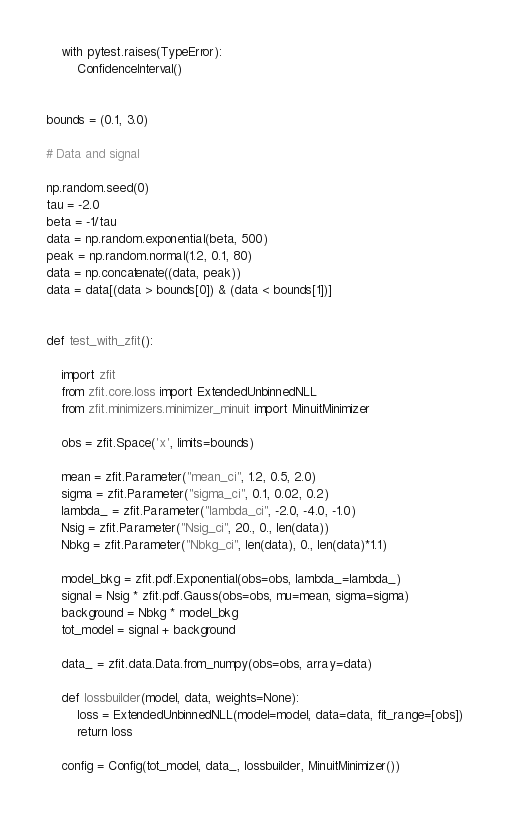Convert code to text. <code><loc_0><loc_0><loc_500><loc_500><_Python_>
    with pytest.raises(TypeError):
        ConfidenceInterval()


bounds = (0.1, 3.0)

# Data and signal

np.random.seed(0)
tau = -2.0
beta = -1/tau
data = np.random.exponential(beta, 500)
peak = np.random.normal(1.2, 0.1, 80)
data = np.concatenate((data, peak))
data = data[(data > bounds[0]) & (data < bounds[1])]


def test_with_zfit():

    import zfit
    from zfit.core.loss import ExtendedUnbinnedNLL
    from zfit.minimizers.minimizer_minuit import MinuitMinimizer

    obs = zfit.Space('x', limits=bounds)

    mean = zfit.Parameter("mean_ci", 1.2, 0.5, 2.0)
    sigma = zfit.Parameter("sigma_ci", 0.1, 0.02, 0.2)
    lambda_ = zfit.Parameter("lambda_ci", -2.0, -4.0, -1.0)
    Nsig = zfit.Parameter("Nsig_ci", 20., 0., len(data))
    Nbkg = zfit.Parameter("Nbkg_ci", len(data), 0., len(data)*1.1)

    model_bkg = zfit.pdf.Exponential(obs=obs, lambda_=lambda_)
    signal = Nsig * zfit.pdf.Gauss(obs=obs, mu=mean, sigma=sigma)
    background = Nbkg * model_bkg
    tot_model = signal + background

    data_ = zfit.data.Data.from_numpy(obs=obs, array=data)

    def lossbuilder(model, data, weights=None):
        loss = ExtendedUnbinnedNLL(model=model, data=data, fit_range=[obs])
        return loss

    config = Config(tot_model, data_, lossbuilder, MinuitMinimizer())
</code> 